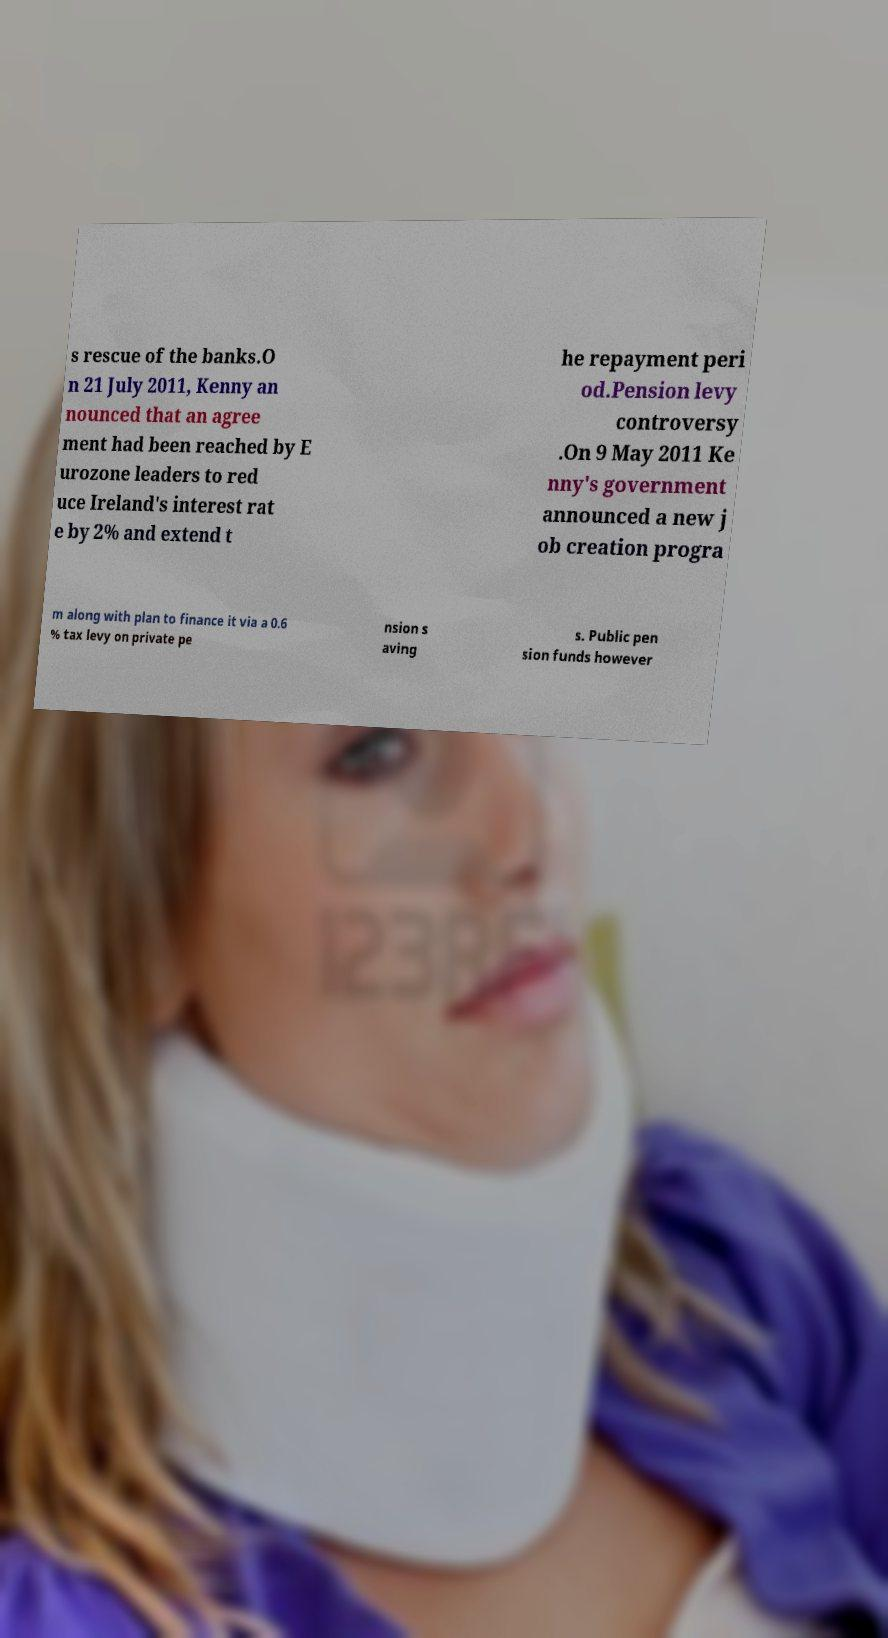Could you extract and type out the text from this image? s rescue of the banks.O n 21 July 2011, Kenny an nounced that an agree ment had been reached by E urozone leaders to red uce Ireland's interest rat e by 2% and extend t he repayment peri od.Pension levy controversy .On 9 May 2011 Ke nny's government announced a new j ob creation progra m along with plan to finance it via a 0.6 % tax levy on private pe nsion s aving s. Public pen sion funds however 